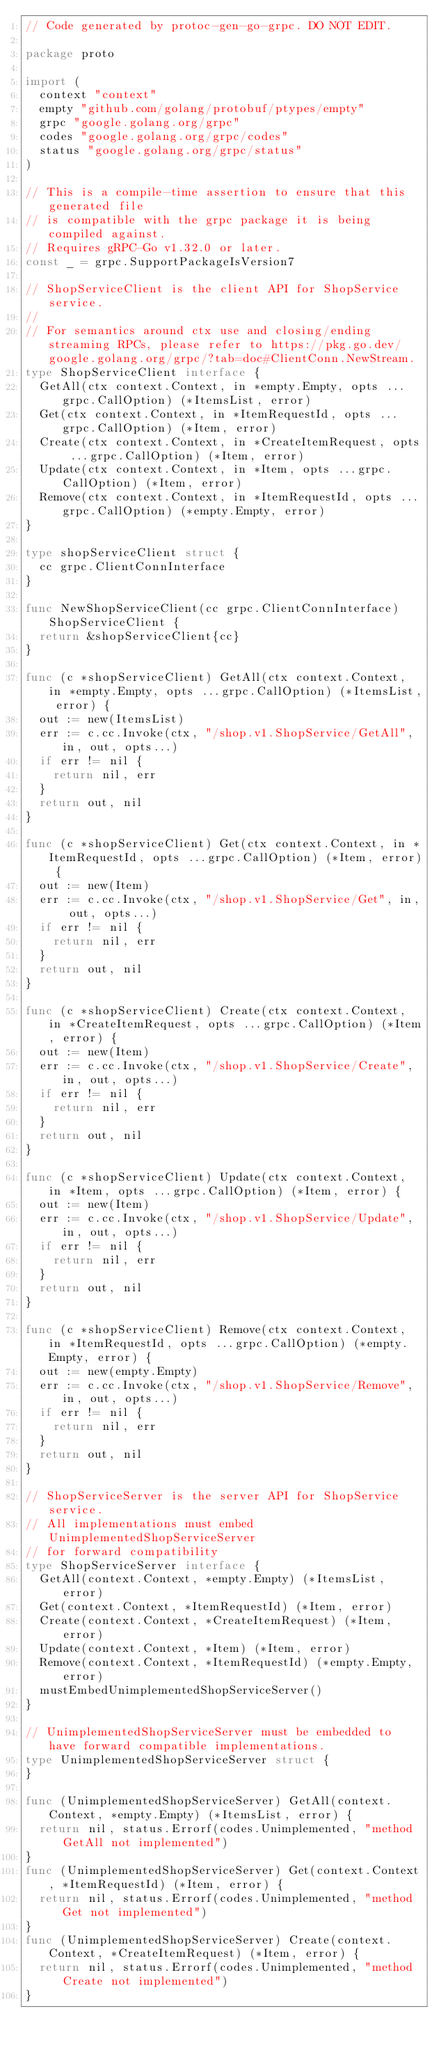<code> <loc_0><loc_0><loc_500><loc_500><_Go_>// Code generated by protoc-gen-go-grpc. DO NOT EDIT.

package proto

import (
	context "context"
	empty "github.com/golang/protobuf/ptypes/empty"
	grpc "google.golang.org/grpc"
	codes "google.golang.org/grpc/codes"
	status "google.golang.org/grpc/status"
)

// This is a compile-time assertion to ensure that this generated file
// is compatible with the grpc package it is being compiled against.
// Requires gRPC-Go v1.32.0 or later.
const _ = grpc.SupportPackageIsVersion7

// ShopServiceClient is the client API for ShopService service.
//
// For semantics around ctx use and closing/ending streaming RPCs, please refer to https://pkg.go.dev/google.golang.org/grpc/?tab=doc#ClientConn.NewStream.
type ShopServiceClient interface {
	GetAll(ctx context.Context, in *empty.Empty, opts ...grpc.CallOption) (*ItemsList, error)
	Get(ctx context.Context, in *ItemRequestId, opts ...grpc.CallOption) (*Item, error)
	Create(ctx context.Context, in *CreateItemRequest, opts ...grpc.CallOption) (*Item, error)
	Update(ctx context.Context, in *Item, opts ...grpc.CallOption) (*Item, error)
	Remove(ctx context.Context, in *ItemRequestId, opts ...grpc.CallOption) (*empty.Empty, error)
}

type shopServiceClient struct {
	cc grpc.ClientConnInterface
}

func NewShopServiceClient(cc grpc.ClientConnInterface) ShopServiceClient {
	return &shopServiceClient{cc}
}

func (c *shopServiceClient) GetAll(ctx context.Context, in *empty.Empty, opts ...grpc.CallOption) (*ItemsList, error) {
	out := new(ItemsList)
	err := c.cc.Invoke(ctx, "/shop.v1.ShopService/GetAll", in, out, opts...)
	if err != nil {
		return nil, err
	}
	return out, nil
}

func (c *shopServiceClient) Get(ctx context.Context, in *ItemRequestId, opts ...grpc.CallOption) (*Item, error) {
	out := new(Item)
	err := c.cc.Invoke(ctx, "/shop.v1.ShopService/Get", in, out, opts...)
	if err != nil {
		return nil, err
	}
	return out, nil
}

func (c *shopServiceClient) Create(ctx context.Context, in *CreateItemRequest, opts ...grpc.CallOption) (*Item, error) {
	out := new(Item)
	err := c.cc.Invoke(ctx, "/shop.v1.ShopService/Create", in, out, opts...)
	if err != nil {
		return nil, err
	}
	return out, nil
}

func (c *shopServiceClient) Update(ctx context.Context, in *Item, opts ...grpc.CallOption) (*Item, error) {
	out := new(Item)
	err := c.cc.Invoke(ctx, "/shop.v1.ShopService/Update", in, out, opts...)
	if err != nil {
		return nil, err
	}
	return out, nil
}

func (c *shopServiceClient) Remove(ctx context.Context, in *ItemRequestId, opts ...grpc.CallOption) (*empty.Empty, error) {
	out := new(empty.Empty)
	err := c.cc.Invoke(ctx, "/shop.v1.ShopService/Remove", in, out, opts...)
	if err != nil {
		return nil, err
	}
	return out, nil
}

// ShopServiceServer is the server API for ShopService service.
// All implementations must embed UnimplementedShopServiceServer
// for forward compatibility
type ShopServiceServer interface {
	GetAll(context.Context, *empty.Empty) (*ItemsList, error)
	Get(context.Context, *ItemRequestId) (*Item, error)
	Create(context.Context, *CreateItemRequest) (*Item, error)
	Update(context.Context, *Item) (*Item, error)
	Remove(context.Context, *ItemRequestId) (*empty.Empty, error)
	mustEmbedUnimplementedShopServiceServer()
}

// UnimplementedShopServiceServer must be embedded to have forward compatible implementations.
type UnimplementedShopServiceServer struct {
}

func (UnimplementedShopServiceServer) GetAll(context.Context, *empty.Empty) (*ItemsList, error) {
	return nil, status.Errorf(codes.Unimplemented, "method GetAll not implemented")
}
func (UnimplementedShopServiceServer) Get(context.Context, *ItemRequestId) (*Item, error) {
	return nil, status.Errorf(codes.Unimplemented, "method Get not implemented")
}
func (UnimplementedShopServiceServer) Create(context.Context, *CreateItemRequest) (*Item, error) {
	return nil, status.Errorf(codes.Unimplemented, "method Create not implemented")
}</code> 